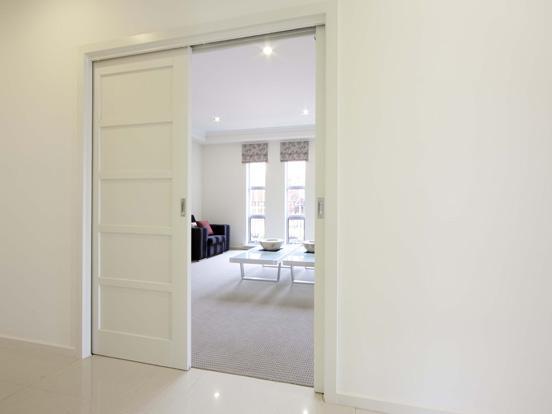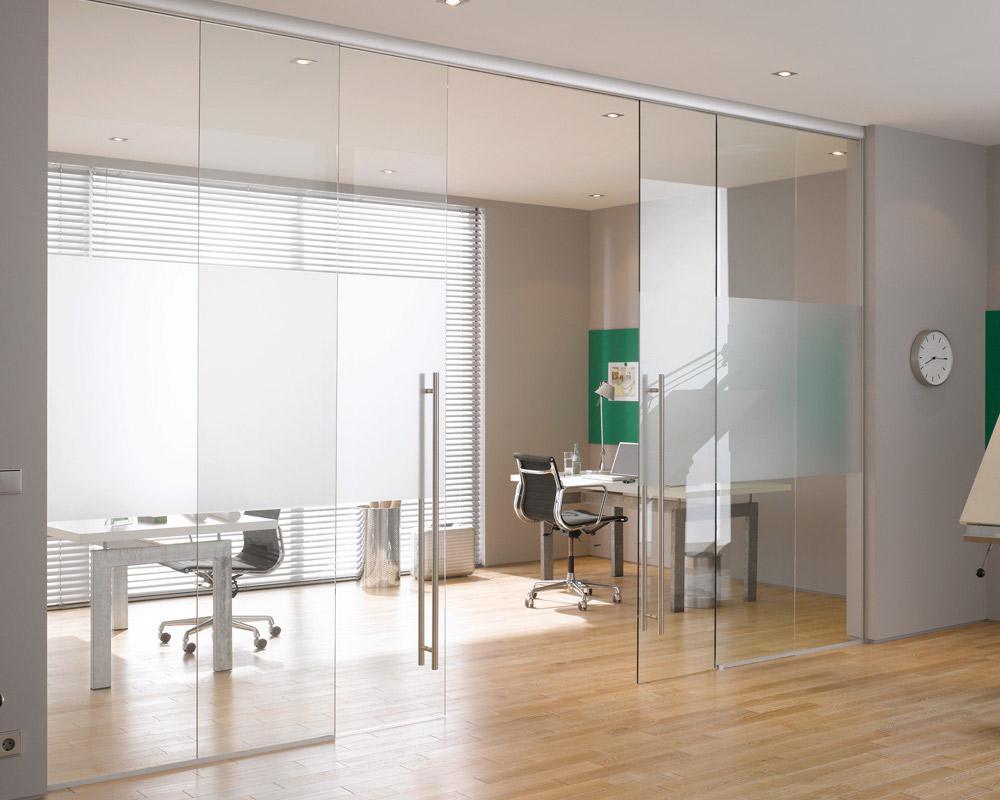The first image is the image on the left, the second image is the image on the right. Analyze the images presented: Is the assertion "One set of sliding doors is white." valid? Answer yes or no. Yes. 